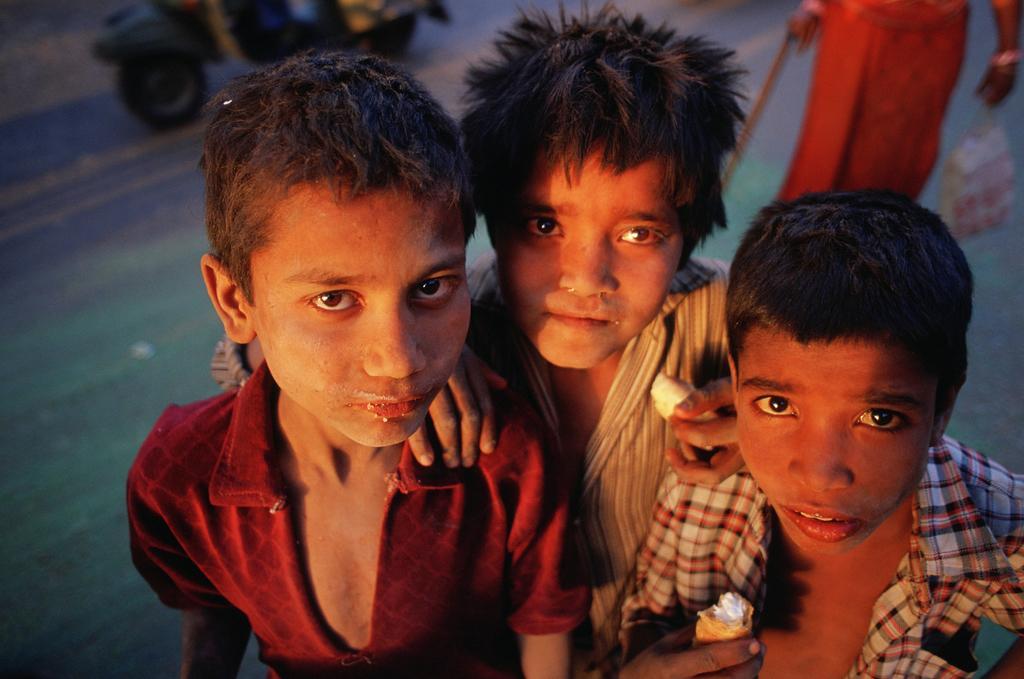In one or two sentences, can you explain what this image depicts? In this image there are three kids holding an object in there hands, in the background there is a vehicle and a person holding a stick and a cover, the kids are wearing red color, strips and checks shirt. 